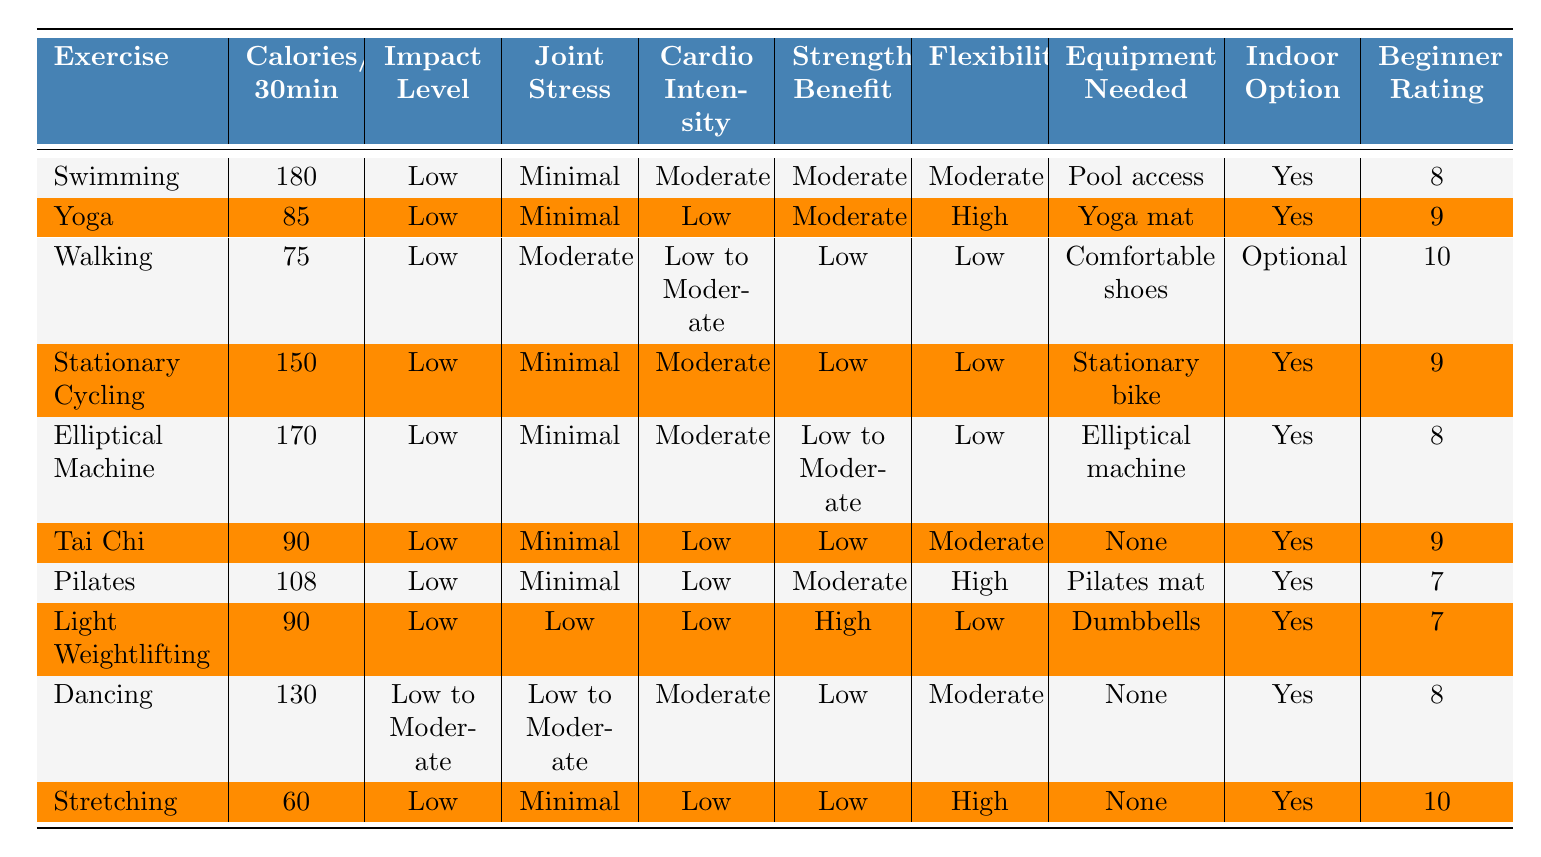What is the exercise that burns the most calories in 30 minutes? In the "Calories/30min" column, Swimming has the highest value at 180 calories burned in 30 minutes.
Answer: Swimming Which exercises have a beginner-friendly rating of 10? In the "Beginner Rating" column, Walking and Stretching both have a rating of 10, indicating they are very beginner-friendly.
Answer: Walking and Stretching What is the average number of calories burned for exercises that require no equipment? The exercises that require no equipment are Tai Chi, Dancing, and Stretching, which burn 90, 130, and 60 calories, respectively. The average is (90 + 130 + 60) / 3 = 280 / 3 ≈ 93.33.
Answer: Approximately 93 calories How many exercises have a low strength benefit rating? We can see in the "Strength Benefit" column that the exercises with a low strength benefit (Low or Low to Moderate) are Walking, Stationary Cycling, Elliptical Machine, Tai Chi, Pilates, Light Weightlifting, and Stretching. Counting them gives us 7 exercises.
Answer: 7 exercises Is Tai Chi a low-impact exercise? The "Impact Level" column indicates that Tai Chi is classified as a low-impact exercise.
Answer: Yes What exercise has the highest flexibility improvement rating? Yoga and Pilates both have high flexibility improvement ratings of  high, but Pilates has a moderate rating. So, Yoga is the one that stands out with a high rating among listed options.
Answer: Yoga Which exercise has a moderate cardio intensity and burns the least calories? In the "Cardio Intensity" column, the exercises with moderate intensity are Swimming, Stationary Cycling, Elliptical Machine, and Dancing. Among these, Walking has the lowest calorie burn at 75 calories.
Answer: Walking How many exercises can be done indoors? All exercises are marked as either yes or optional in the "Indoor Option" column. Counting them reveals that all 10 exercises can be done indoors.
Answer: 10 exercises What is the difference in calories burned between the highest and lowest calorie-burning exercises? The highest calorie-burning exercise is Swimming with 180 calories, and the lowest is Stretching with 60 calories. The difference is 180 - 60 = 120 calories.
Answer: 120 calories Which exercise provides both moderate strength benefit and flexibility improvement? In the table, we find Yoga and Pilates have moderate strength benefit. Comparing the flexibility improvement rating, Yoga has a high rating, making it the only exercise that fulfills both conditions among the list.
Answer: Yoga 